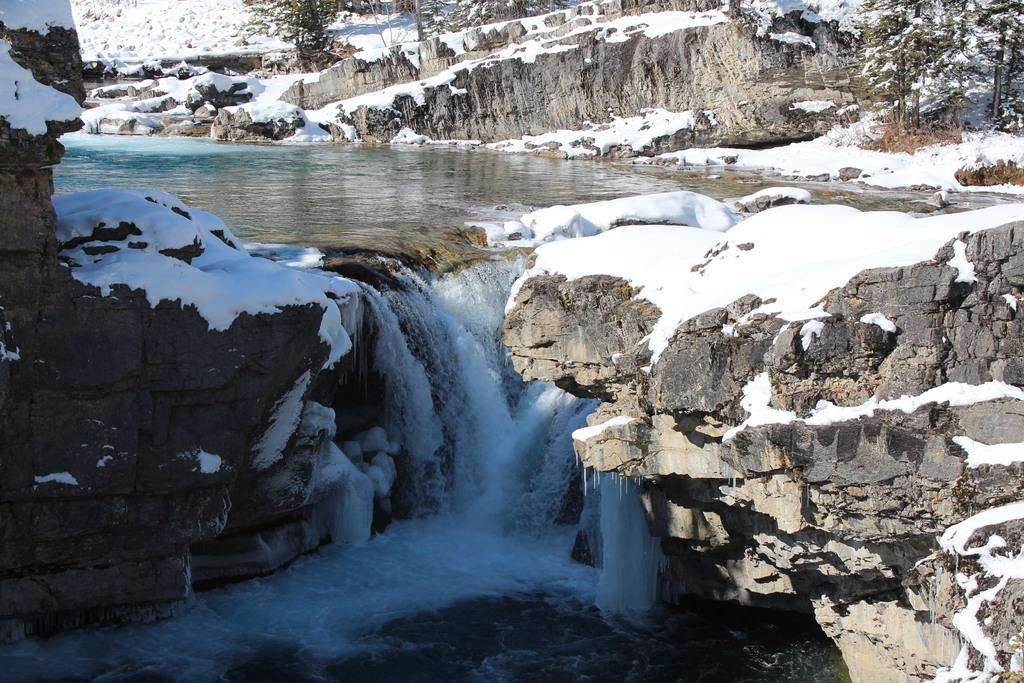What type of weather condition is depicted in the image? There is snow in the image, indicating a cold weather condition. What is the other liquid substance visible in the image? There is water in the image. What type of natural features can be seen in the image? There are rocks and trees in the image. How many hearts can be seen in the image? There are no hearts visible in the image. Are there any boats present in the image? There are no boats present in the image. 